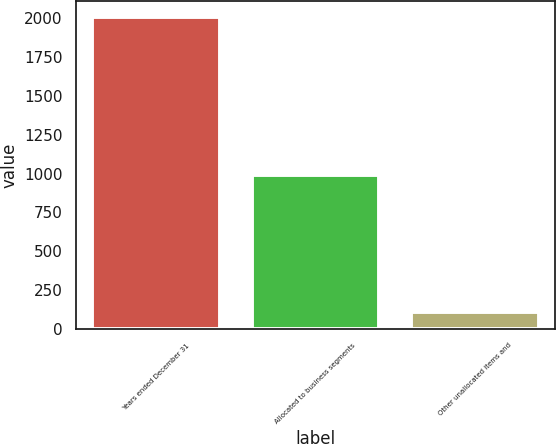Convert chart. <chart><loc_0><loc_0><loc_500><loc_500><bar_chart><fcel>Years ended December 31<fcel>Allocated to business segments<fcel>Other unallocated items and<nl><fcel>2009<fcel>989<fcel>110<nl></chart> 